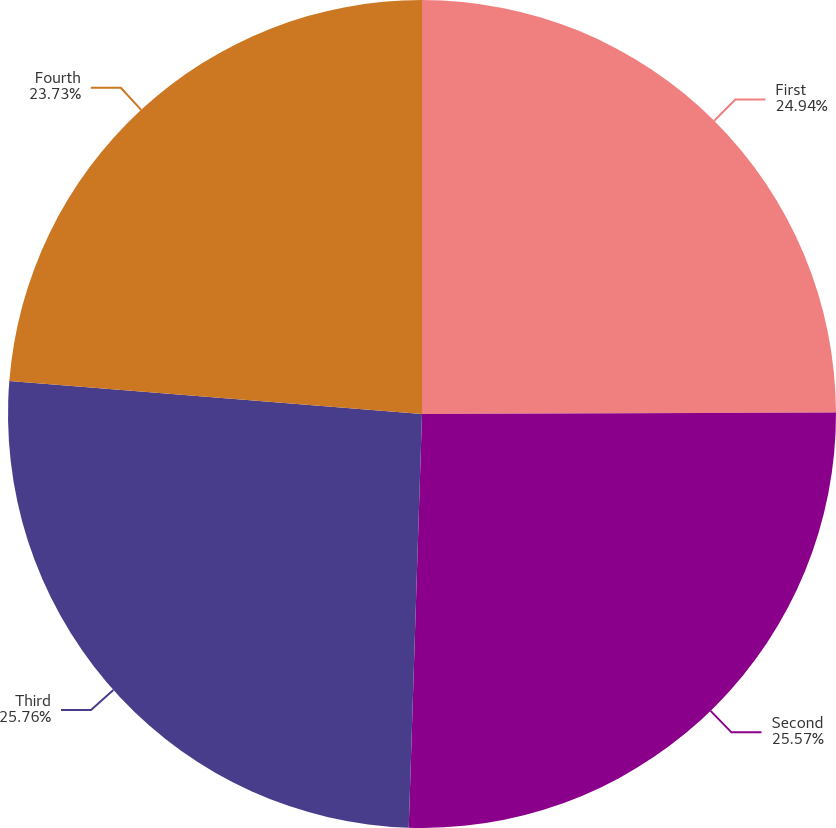Convert chart. <chart><loc_0><loc_0><loc_500><loc_500><pie_chart><fcel>First<fcel>Second<fcel>Third<fcel>Fourth<nl><fcel>24.94%<fcel>25.57%<fcel>25.76%<fcel>23.73%<nl></chart> 